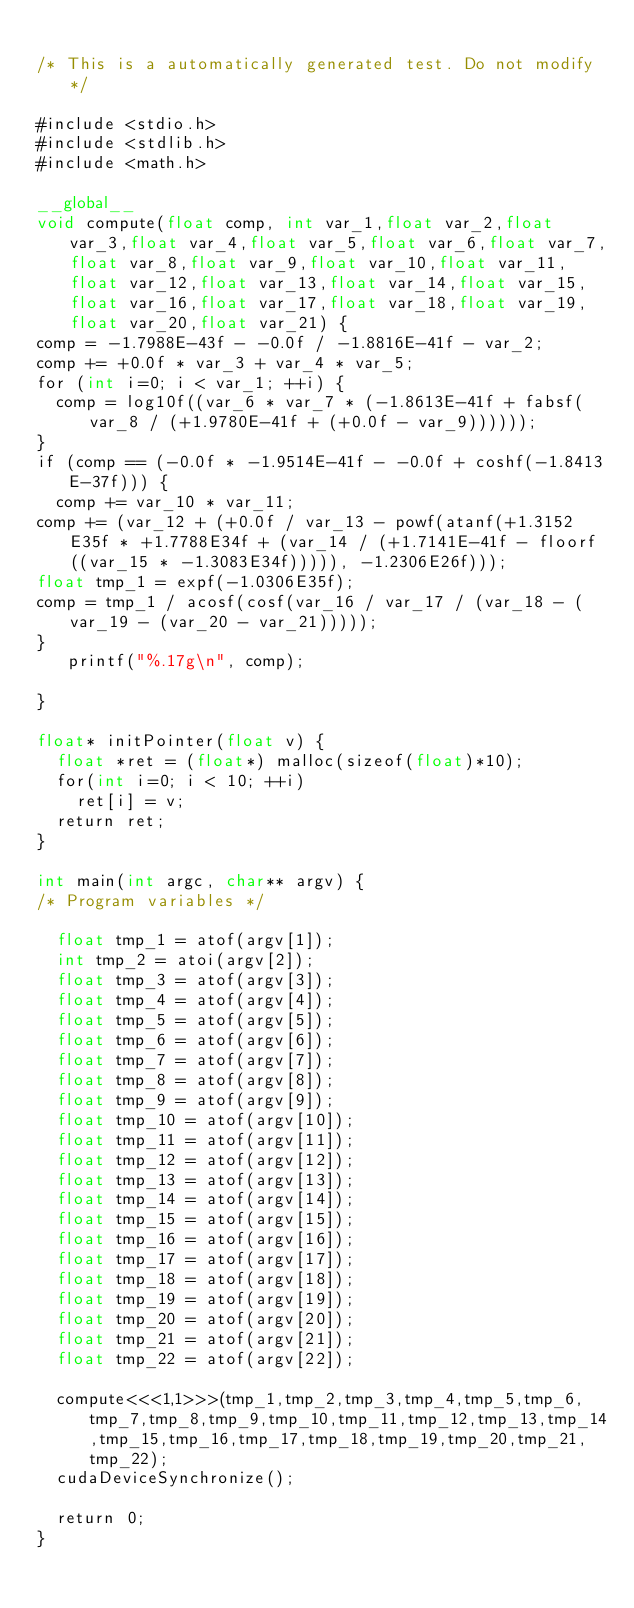<code> <loc_0><loc_0><loc_500><loc_500><_Cuda_>
/* This is a automatically generated test. Do not modify */

#include <stdio.h>
#include <stdlib.h>
#include <math.h>

__global__
void compute(float comp, int var_1,float var_2,float var_3,float var_4,float var_5,float var_6,float var_7,float var_8,float var_9,float var_10,float var_11,float var_12,float var_13,float var_14,float var_15,float var_16,float var_17,float var_18,float var_19,float var_20,float var_21) {
comp = -1.7988E-43f - -0.0f / -1.8816E-41f - var_2;
comp += +0.0f * var_3 + var_4 * var_5;
for (int i=0; i < var_1; ++i) {
  comp = log10f((var_6 * var_7 * (-1.8613E-41f + fabsf(var_8 / (+1.9780E-41f + (+0.0f - var_9))))));
}
if (comp == (-0.0f * -1.9514E-41f - -0.0f + coshf(-1.8413E-37f))) {
  comp += var_10 * var_11;
comp += (var_12 + (+0.0f / var_13 - powf(atanf(+1.3152E35f * +1.7788E34f + (var_14 / (+1.7141E-41f - floorf((var_15 * -1.3083E34f))))), -1.2306E26f)));
float tmp_1 = expf(-1.0306E35f);
comp = tmp_1 / acosf(cosf(var_16 / var_17 / (var_18 - (var_19 - (var_20 - var_21)))));
}
   printf("%.17g\n", comp);

}

float* initPointer(float v) {
  float *ret = (float*) malloc(sizeof(float)*10);
  for(int i=0; i < 10; ++i)
    ret[i] = v;
  return ret;
}

int main(int argc, char** argv) {
/* Program variables */

  float tmp_1 = atof(argv[1]);
  int tmp_2 = atoi(argv[2]);
  float tmp_3 = atof(argv[3]);
  float tmp_4 = atof(argv[4]);
  float tmp_5 = atof(argv[5]);
  float tmp_6 = atof(argv[6]);
  float tmp_7 = atof(argv[7]);
  float tmp_8 = atof(argv[8]);
  float tmp_9 = atof(argv[9]);
  float tmp_10 = atof(argv[10]);
  float tmp_11 = atof(argv[11]);
  float tmp_12 = atof(argv[12]);
  float tmp_13 = atof(argv[13]);
  float tmp_14 = atof(argv[14]);
  float tmp_15 = atof(argv[15]);
  float tmp_16 = atof(argv[16]);
  float tmp_17 = atof(argv[17]);
  float tmp_18 = atof(argv[18]);
  float tmp_19 = atof(argv[19]);
  float tmp_20 = atof(argv[20]);
  float tmp_21 = atof(argv[21]);
  float tmp_22 = atof(argv[22]);

  compute<<<1,1>>>(tmp_1,tmp_2,tmp_3,tmp_4,tmp_5,tmp_6,tmp_7,tmp_8,tmp_9,tmp_10,tmp_11,tmp_12,tmp_13,tmp_14,tmp_15,tmp_16,tmp_17,tmp_18,tmp_19,tmp_20,tmp_21,tmp_22);
  cudaDeviceSynchronize();

  return 0;
}
</code> 